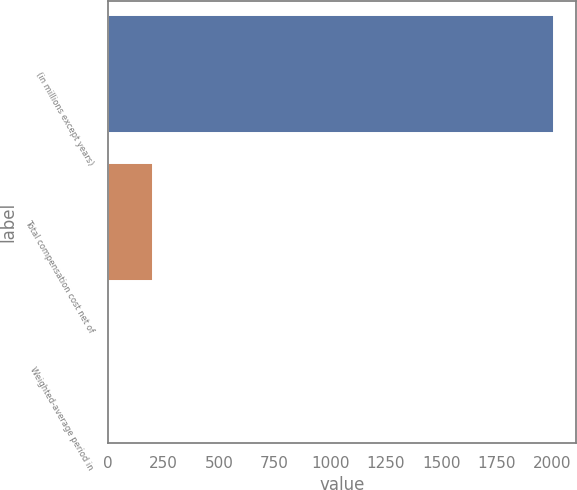Convert chart to OTSL. <chart><loc_0><loc_0><loc_500><loc_500><bar_chart><fcel>(in millions except years)<fcel>Total compensation cost net of<fcel>Weighted-average period in<nl><fcel>2008<fcel>202.51<fcel>1.9<nl></chart> 